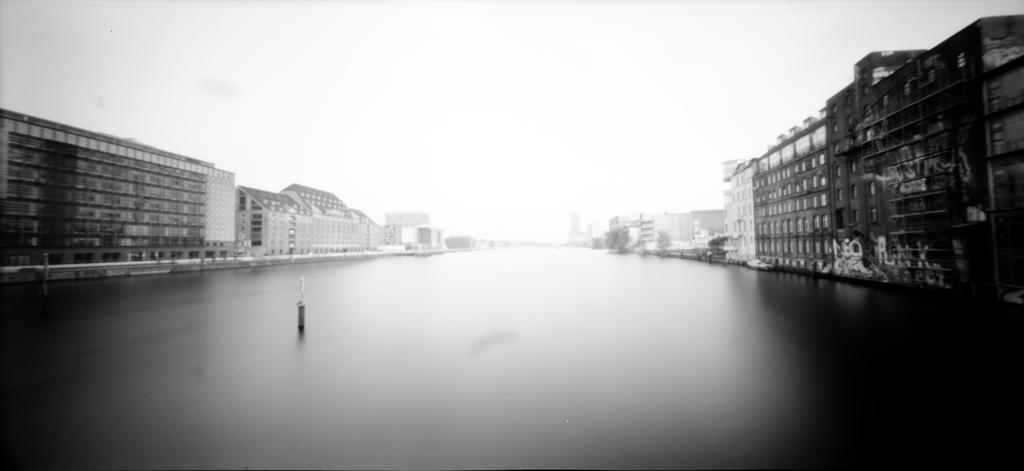What is the color scheme of the image? The image is black and white. What can be seen in the path? There is an object in the path. What type of structures are visible on both sides of the path? There are buildings visible on both sides of the path. What type of skin condition can be seen on the object in the path? There is no skin condition visible on the object in the path, as the image is black and white and does not show any details related to skin. 